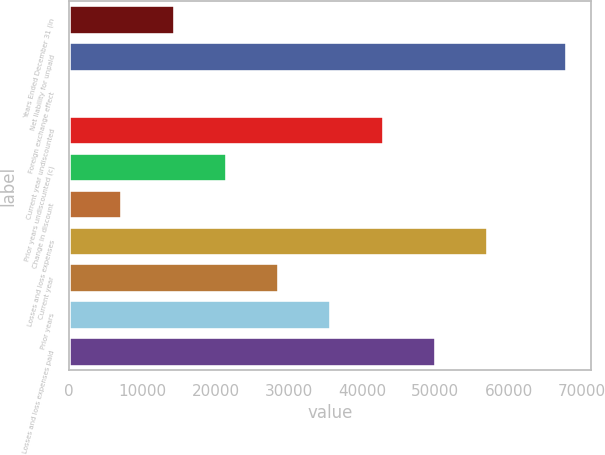<chart> <loc_0><loc_0><loc_500><loc_500><bar_chart><fcel>Years Ended December 31 (in<fcel>Net liability for unpaid<fcel>Foreign exchange effect<fcel>Current year undiscounted<fcel>Prior years undiscounted (c)<fcel>Change in discount<fcel>Losses and loss expenses<fcel>Current year<fcel>Prior years<fcel>Losses and loss expenses paid<nl><fcel>14402.2<fcel>67899<fcel>126<fcel>42954.6<fcel>21540.3<fcel>7264.1<fcel>57230.8<fcel>28678.4<fcel>35816.5<fcel>50092.7<nl></chart> 